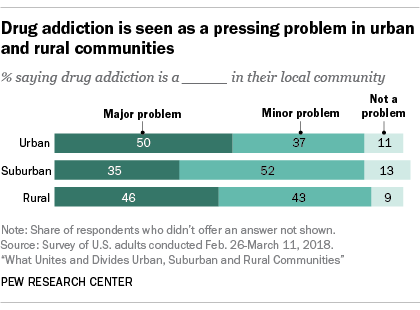Draw attention to some important aspects in this diagram. Can you identify the smallest value in the given graph? It is 9. The total of all dark blue bars is greater than the total of all light blue bars. 